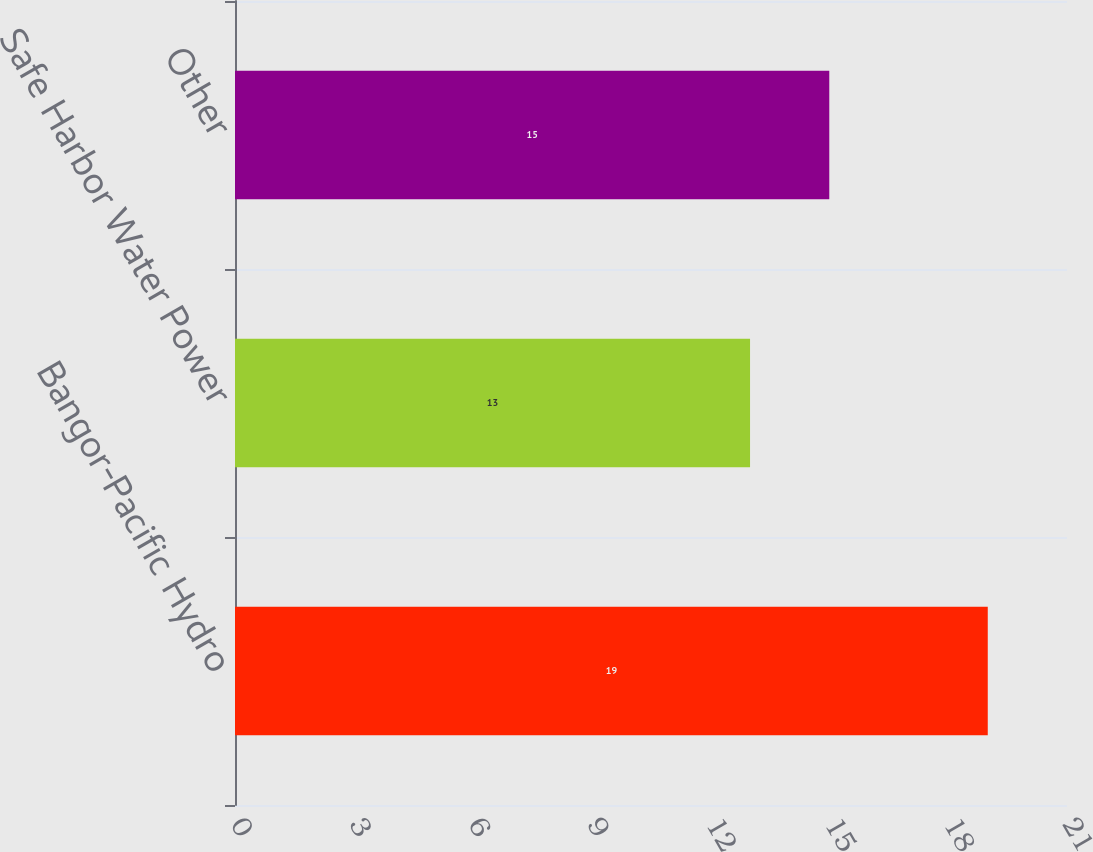Convert chart to OTSL. <chart><loc_0><loc_0><loc_500><loc_500><bar_chart><fcel>Bangor-Pacific Hydro<fcel>Safe Harbor Water Power<fcel>Other<nl><fcel>19<fcel>13<fcel>15<nl></chart> 